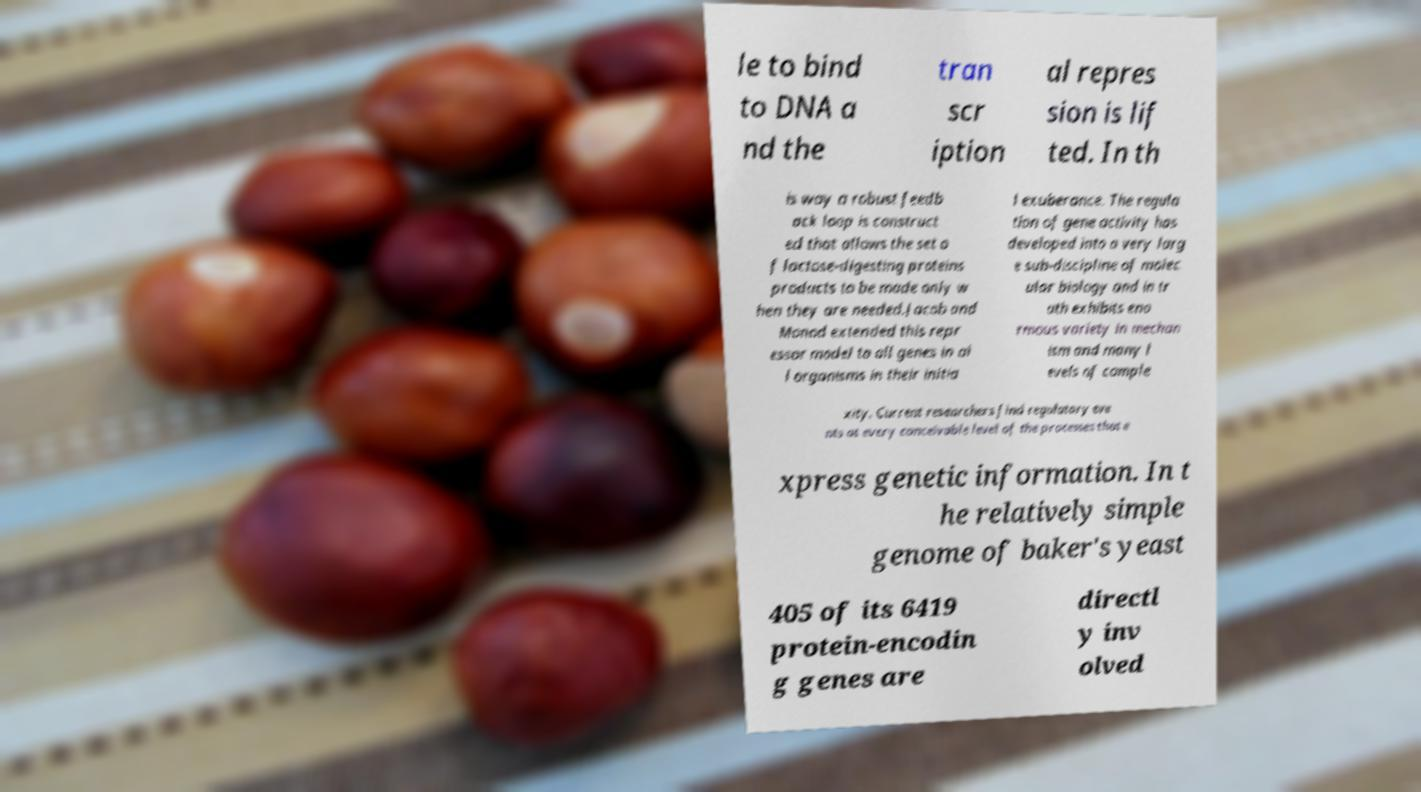Could you extract and type out the text from this image? le to bind to DNA a nd the tran scr iption al repres sion is lif ted. In th is way a robust feedb ack loop is construct ed that allows the set o f lactose-digesting proteins products to be made only w hen they are needed.Jacob and Monod extended this repr essor model to all genes in al l organisms in their initia l exuberance. The regula tion of gene activity has developed into a very larg e sub-discipline of molec ular biology and in tr uth exhibits eno rmous variety in mechan ism and many l evels of comple xity. Current researchers find regulatory eve nts at every conceivable level of the processes that e xpress genetic information. In t he relatively simple genome of baker's yeast 405 of its 6419 protein-encodin g genes are directl y inv olved 